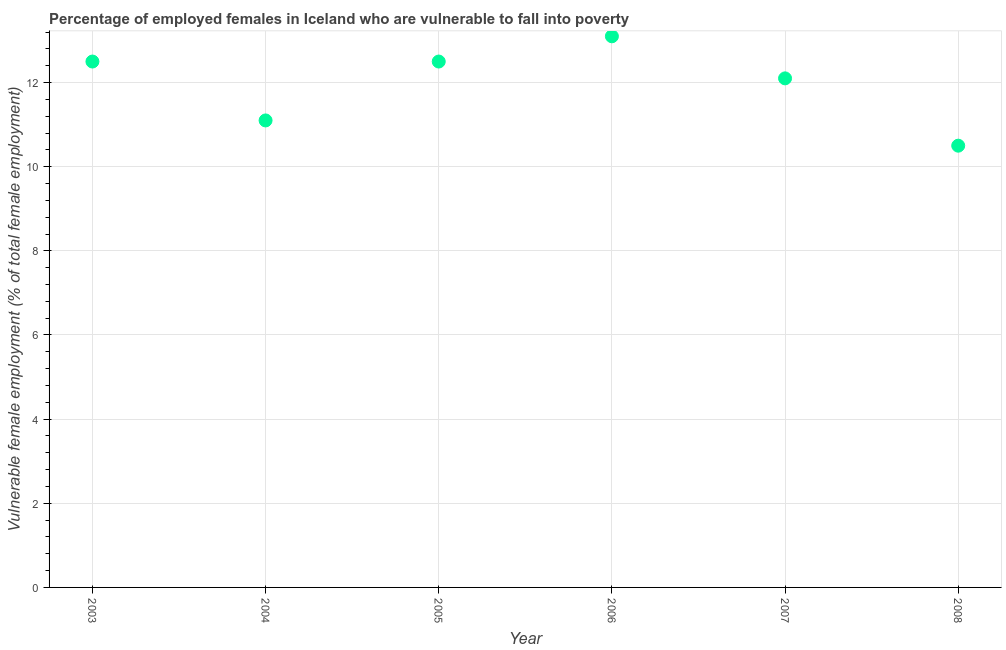What is the percentage of employed females who are vulnerable to fall into poverty in 2006?
Give a very brief answer. 13.1. Across all years, what is the maximum percentage of employed females who are vulnerable to fall into poverty?
Offer a terse response. 13.1. In which year was the percentage of employed females who are vulnerable to fall into poverty minimum?
Give a very brief answer. 2008. What is the sum of the percentage of employed females who are vulnerable to fall into poverty?
Provide a short and direct response. 71.8. What is the difference between the percentage of employed females who are vulnerable to fall into poverty in 2005 and 2007?
Ensure brevity in your answer.  0.4. What is the average percentage of employed females who are vulnerable to fall into poverty per year?
Your answer should be very brief. 11.97. What is the median percentage of employed females who are vulnerable to fall into poverty?
Keep it short and to the point. 12.3. In how many years, is the percentage of employed females who are vulnerable to fall into poverty greater than 7.6 %?
Provide a short and direct response. 6. Do a majority of the years between 2005 and 2008 (inclusive) have percentage of employed females who are vulnerable to fall into poverty greater than 11.2 %?
Give a very brief answer. Yes. What is the ratio of the percentage of employed females who are vulnerable to fall into poverty in 2005 to that in 2007?
Your answer should be very brief. 1.03. What is the difference between the highest and the second highest percentage of employed females who are vulnerable to fall into poverty?
Your answer should be compact. 0.6. Is the sum of the percentage of employed females who are vulnerable to fall into poverty in 2005 and 2008 greater than the maximum percentage of employed females who are vulnerable to fall into poverty across all years?
Your response must be concise. Yes. What is the difference between the highest and the lowest percentage of employed females who are vulnerable to fall into poverty?
Provide a short and direct response. 2.6. In how many years, is the percentage of employed females who are vulnerable to fall into poverty greater than the average percentage of employed females who are vulnerable to fall into poverty taken over all years?
Offer a very short reply. 4. How many years are there in the graph?
Offer a very short reply. 6. What is the difference between two consecutive major ticks on the Y-axis?
Your answer should be compact. 2. Are the values on the major ticks of Y-axis written in scientific E-notation?
Your answer should be very brief. No. What is the title of the graph?
Provide a short and direct response. Percentage of employed females in Iceland who are vulnerable to fall into poverty. What is the label or title of the X-axis?
Keep it short and to the point. Year. What is the label or title of the Y-axis?
Make the answer very short. Vulnerable female employment (% of total female employment). What is the Vulnerable female employment (% of total female employment) in 2004?
Provide a succinct answer. 11.1. What is the Vulnerable female employment (% of total female employment) in 2006?
Provide a succinct answer. 13.1. What is the Vulnerable female employment (% of total female employment) in 2007?
Your answer should be very brief. 12.1. What is the Vulnerable female employment (% of total female employment) in 2008?
Keep it short and to the point. 10.5. What is the difference between the Vulnerable female employment (% of total female employment) in 2003 and 2004?
Offer a terse response. 1.4. What is the difference between the Vulnerable female employment (% of total female employment) in 2003 and 2005?
Offer a very short reply. 0. What is the difference between the Vulnerable female employment (% of total female employment) in 2004 and 2005?
Offer a terse response. -1.4. What is the difference between the Vulnerable female employment (% of total female employment) in 2004 and 2008?
Your answer should be very brief. 0.6. What is the difference between the Vulnerable female employment (% of total female employment) in 2005 and 2006?
Offer a very short reply. -0.6. What is the difference between the Vulnerable female employment (% of total female employment) in 2007 and 2008?
Give a very brief answer. 1.6. What is the ratio of the Vulnerable female employment (% of total female employment) in 2003 to that in 2004?
Your answer should be very brief. 1.13. What is the ratio of the Vulnerable female employment (% of total female employment) in 2003 to that in 2006?
Offer a terse response. 0.95. What is the ratio of the Vulnerable female employment (% of total female employment) in 2003 to that in 2007?
Offer a terse response. 1.03. What is the ratio of the Vulnerable female employment (% of total female employment) in 2003 to that in 2008?
Make the answer very short. 1.19. What is the ratio of the Vulnerable female employment (% of total female employment) in 2004 to that in 2005?
Give a very brief answer. 0.89. What is the ratio of the Vulnerable female employment (% of total female employment) in 2004 to that in 2006?
Provide a short and direct response. 0.85. What is the ratio of the Vulnerable female employment (% of total female employment) in 2004 to that in 2007?
Your answer should be very brief. 0.92. What is the ratio of the Vulnerable female employment (% of total female employment) in 2004 to that in 2008?
Provide a short and direct response. 1.06. What is the ratio of the Vulnerable female employment (% of total female employment) in 2005 to that in 2006?
Provide a succinct answer. 0.95. What is the ratio of the Vulnerable female employment (% of total female employment) in 2005 to that in 2007?
Provide a succinct answer. 1.03. What is the ratio of the Vulnerable female employment (% of total female employment) in 2005 to that in 2008?
Provide a short and direct response. 1.19. What is the ratio of the Vulnerable female employment (% of total female employment) in 2006 to that in 2007?
Provide a succinct answer. 1.08. What is the ratio of the Vulnerable female employment (% of total female employment) in 2006 to that in 2008?
Keep it short and to the point. 1.25. What is the ratio of the Vulnerable female employment (% of total female employment) in 2007 to that in 2008?
Keep it short and to the point. 1.15. 